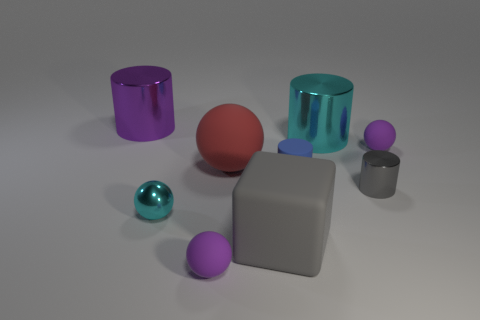What number of blocks are either gray matte objects or big green matte objects?
Provide a succinct answer. 1. What is the size of the object that is the same color as the small shiny cylinder?
Offer a very short reply. Large. Are there fewer small shiny objects that are behind the tiny cyan metallic object than large blue rubber spheres?
Keep it short and to the point. No. There is a small matte object that is in front of the red rubber sphere and behind the large gray matte thing; what is its color?
Offer a terse response. Blue. What number of other things are there of the same shape as the gray matte object?
Keep it short and to the point. 0. Is the number of big purple metal cylinders on the left side of the blue thing less than the number of things that are in front of the big red object?
Keep it short and to the point. Yes. Are the cyan sphere and the small purple sphere that is on the left side of the small blue rubber cylinder made of the same material?
Make the answer very short. No. Is there any other thing that has the same material as the cube?
Make the answer very short. Yes. Is the number of small blue cylinders greater than the number of small matte spheres?
Provide a succinct answer. No. What is the shape of the big thing that is on the left side of the tiny cyan metal thing that is to the left of the small purple rubber thing in front of the gray matte thing?
Ensure brevity in your answer.  Cylinder. 